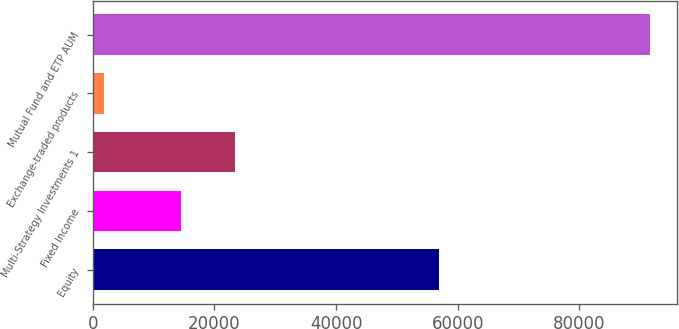<chart> <loc_0><loc_0><loc_500><loc_500><bar_chart><fcel>Equity<fcel>Fixed Income<fcel>Multi-Strategy Investments 1<fcel>Exchange-traded products<fcel>Mutual Fund and ETP AUM<nl><fcel>56986<fcel>14467<fcel>23435.6<fcel>1871<fcel>91557<nl></chart> 